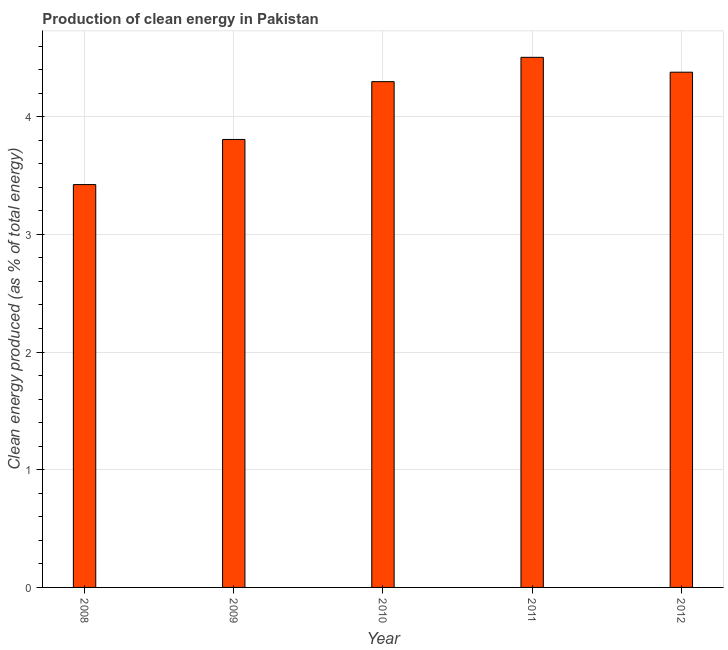What is the title of the graph?
Your answer should be compact. Production of clean energy in Pakistan. What is the label or title of the Y-axis?
Your response must be concise. Clean energy produced (as % of total energy). What is the production of clean energy in 2012?
Your answer should be very brief. 4.38. Across all years, what is the maximum production of clean energy?
Ensure brevity in your answer.  4.5. Across all years, what is the minimum production of clean energy?
Your answer should be compact. 3.42. What is the sum of the production of clean energy?
Offer a terse response. 20.41. What is the difference between the production of clean energy in 2010 and 2011?
Offer a very short reply. -0.21. What is the average production of clean energy per year?
Your response must be concise. 4.08. What is the median production of clean energy?
Provide a short and direct response. 4.3. What is the ratio of the production of clean energy in 2008 to that in 2012?
Keep it short and to the point. 0.78. Is the difference between the production of clean energy in 2009 and 2012 greater than the difference between any two years?
Offer a terse response. No. What is the difference between the highest and the second highest production of clean energy?
Keep it short and to the point. 0.13. What is the difference between the highest and the lowest production of clean energy?
Your answer should be very brief. 1.08. In how many years, is the production of clean energy greater than the average production of clean energy taken over all years?
Provide a short and direct response. 3. How many bars are there?
Ensure brevity in your answer.  5. What is the difference between two consecutive major ticks on the Y-axis?
Keep it short and to the point. 1. Are the values on the major ticks of Y-axis written in scientific E-notation?
Offer a very short reply. No. What is the Clean energy produced (as % of total energy) in 2008?
Make the answer very short. 3.42. What is the Clean energy produced (as % of total energy) of 2009?
Your answer should be very brief. 3.81. What is the Clean energy produced (as % of total energy) of 2010?
Provide a short and direct response. 4.3. What is the Clean energy produced (as % of total energy) in 2011?
Offer a terse response. 4.5. What is the Clean energy produced (as % of total energy) of 2012?
Provide a succinct answer. 4.38. What is the difference between the Clean energy produced (as % of total energy) in 2008 and 2009?
Ensure brevity in your answer.  -0.38. What is the difference between the Clean energy produced (as % of total energy) in 2008 and 2010?
Offer a terse response. -0.87. What is the difference between the Clean energy produced (as % of total energy) in 2008 and 2011?
Your answer should be compact. -1.08. What is the difference between the Clean energy produced (as % of total energy) in 2008 and 2012?
Your response must be concise. -0.95. What is the difference between the Clean energy produced (as % of total energy) in 2009 and 2010?
Give a very brief answer. -0.49. What is the difference between the Clean energy produced (as % of total energy) in 2009 and 2011?
Offer a terse response. -0.7. What is the difference between the Clean energy produced (as % of total energy) in 2009 and 2012?
Your answer should be very brief. -0.57. What is the difference between the Clean energy produced (as % of total energy) in 2010 and 2011?
Make the answer very short. -0.21. What is the difference between the Clean energy produced (as % of total energy) in 2010 and 2012?
Provide a short and direct response. -0.08. What is the difference between the Clean energy produced (as % of total energy) in 2011 and 2012?
Provide a short and direct response. 0.13. What is the ratio of the Clean energy produced (as % of total energy) in 2008 to that in 2009?
Your answer should be very brief. 0.9. What is the ratio of the Clean energy produced (as % of total energy) in 2008 to that in 2010?
Your response must be concise. 0.8. What is the ratio of the Clean energy produced (as % of total energy) in 2008 to that in 2011?
Offer a very short reply. 0.76. What is the ratio of the Clean energy produced (as % of total energy) in 2008 to that in 2012?
Your answer should be compact. 0.78. What is the ratio of the Clean energy produced (as % of total energy) in 2009 to that in 2010?
Offer a terse response. 0.89. What is the ratio of the Clean energy produced (as % of total energy) in 2009 to that in 2011?
Provide a short and direct response. 0.84. What is the ratio of the Clean energy produced (as % of total energy) in 2009 to that in 2012?
Provide a succinct answer. 0.87. What is the ratio of the Clean energy produced (as % of total energy) in 2010 to that in 2011?
Provide a succinct answer. 0.95. What is the ratio of the Clean energy produced (as % of total energy) in 2010 to that in 2012?
Your answer should be very brief. 0.98. 